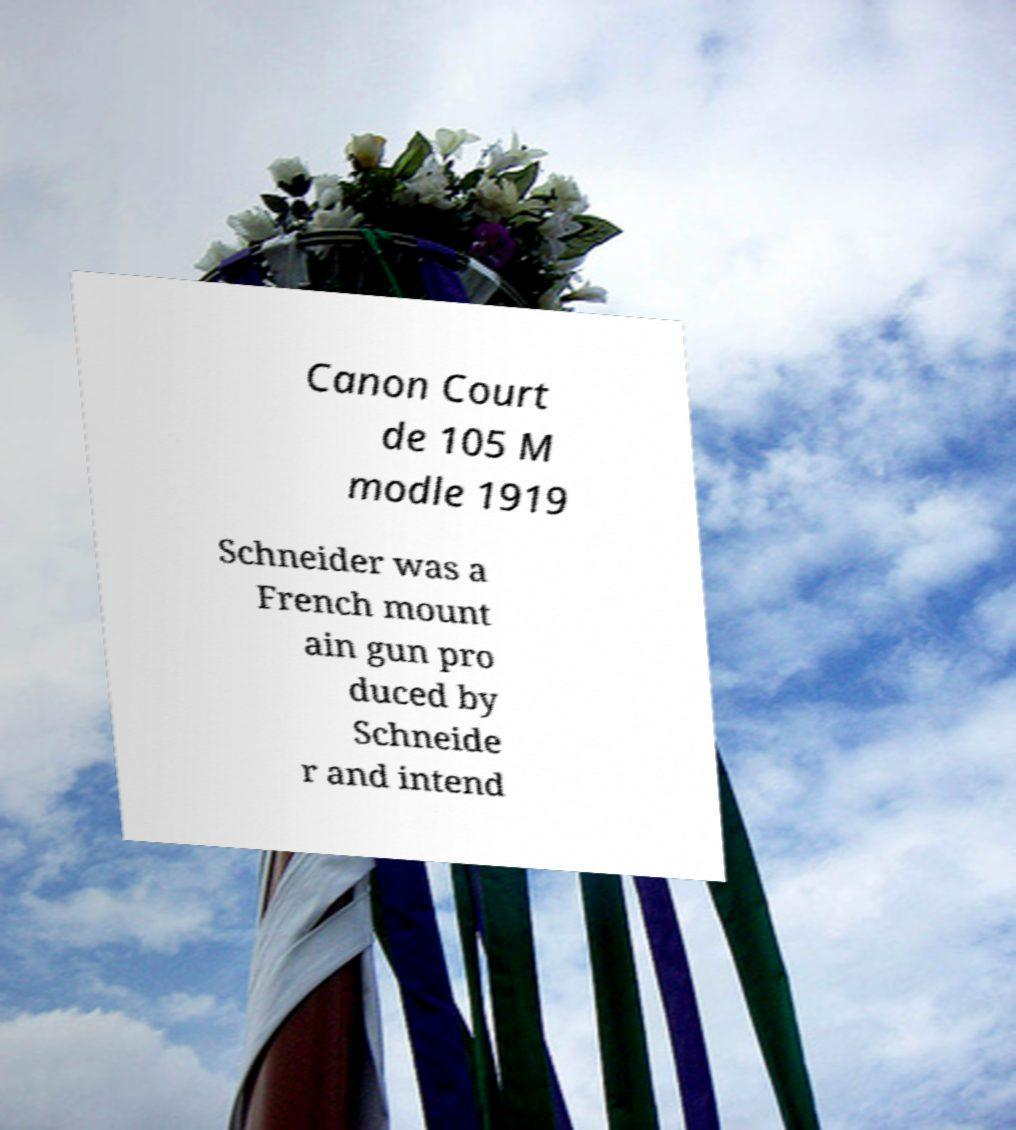I need the written content from this picture converted into text. Can you do that? Canon Court de 105 M modle 1919 Schneider was a French mount ain gun pro duced by Schneide r and intend 